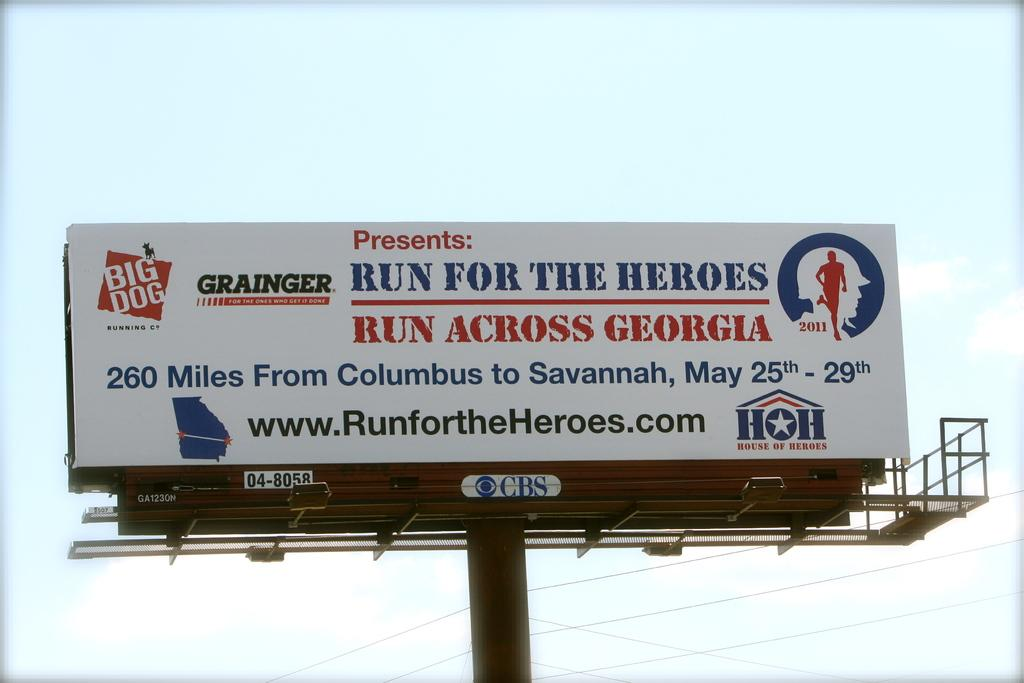<image>
Create a compact narrative representing the image presented. A billboard advertisement for a charity run across Georgia 